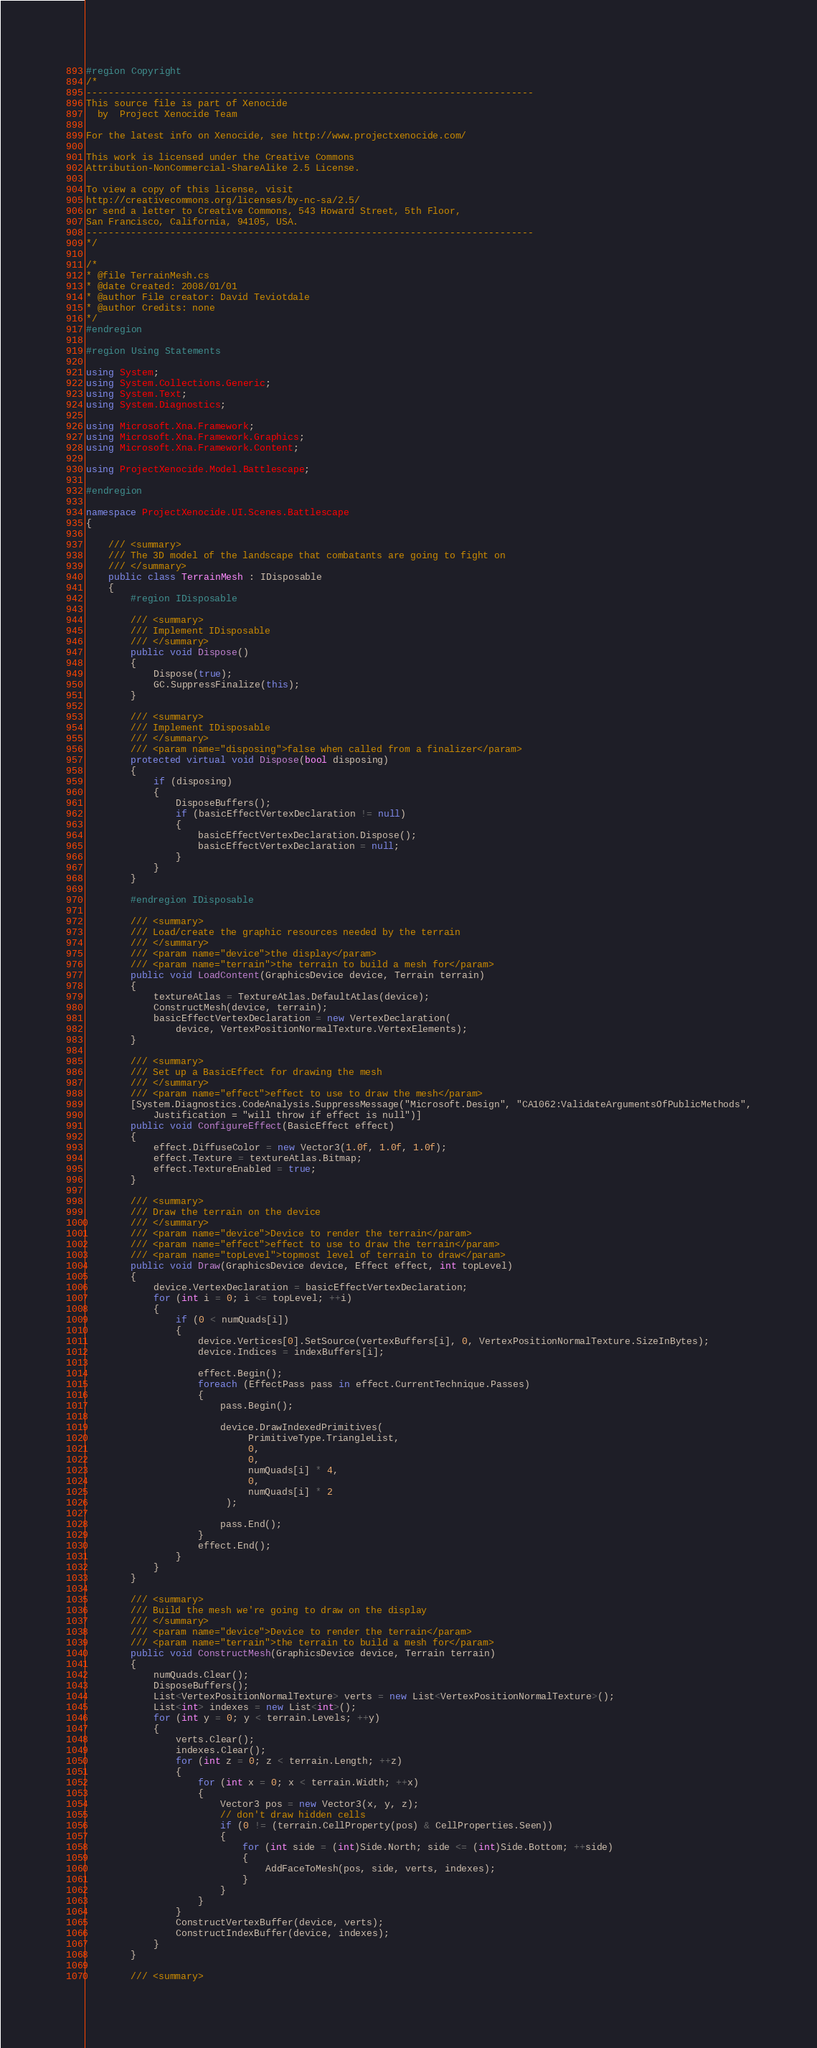Convert code to text. <code><loc_0><loc_0><loc_500><loc_500><_C#_>#region Copyright
/*
--------------------------------------------------------------------------------
This source file is part of Xenocide
  by  Project Xenocide Team

For the latest info on Xenocide, see http://www.projectxenocide.com/

This work is licensed under the Creative Commons
Attribution-NonCommercial-ShareAlike 2.5 License.

To view a copy of this license, visit
http://creativecommons.org/licenses/by-nc-sa/2.5/
or send a letter to Creative Commons, 543 Howard Street, 5th Floor,
San Francisco, California, 94105, USA.
--------------------------------------------------------------------------------
*/

/*
* @file TerrainMesh.cs
* @date Created: 2008/01/01
* @author File creator: David Teviotdale
* @author Credits: none
*/
#endregion

#region Using Statements

using System;
using System.Collections.Generic;
using System.Text;
using System.Diagnostics;

using Microsoft.Xna.Framework;
using Microsoft.Xna.Framework.Graphics;
using Microsoft.Xna.Framework.Content;

using ProjectXenocide.Model.Battlescape;

#endregion

namespace ProjectXenocide.UI.Scenes.Battlescape
{

    /// <summary>
    /// The 3D model of the landscape that combatants are going to fight on
    /// </summary>
    public class TerrainMesh : IDisposable
    {
        #region IDisposable

        /// <summary>
        /// Implement IDisposable
        /// </summary>
        public void Dispose()
        {
            Dispose(true);
            GC.SuppressFinalize(this);
        }

        /// <summary>
        /// Implement IDisposable
        /// </summary>
        /// <param name="disposing">false when called from a finalizer</param>
        protected virtual void Dispose(bool disposing)
        {
            if (disposing)
            {
                DisposeBuffers();
                if (basicEffectVertexDeclaration != null)
                {
                    basicEffectVertexDeclaration.Dispose();
                    basicEffectVertexDeclaration = null;
                }
            }
        }

        #endregion IDisposable

        /// <summary>
        /// Load/create the graphic resources needed by the terrain
        /// </summary>
        /// <param name="device">the display</param>
        /// <param name="terrain">the terrain to build a mesh for</param>
        public void LoadContent(GraphicsDevice device, Terrain terrain)
        {
            textureAtlas = TextureAtlas.DefaultAtlas(device);
            ConstructMesh(device, terrain);
            basicEffectVertexDeclaration = new VertexDeclaration(
                device, VertexPositionNormalTexture.VertexElements);
        }

        /// <summary>
        /// Set up a BasicEffect for drawing the mesh
        /// </summary>
        /// <param name="effect">effect to use to draw the mesh</param>
        [System.Diagnostics.CodeAnalysis.SuppressMessage("Microsoft.Design", "CA1062:ValidateArgumentsOfPublicMethods",
            Justification = "will throw if effect is null")]
        public void ConfigureEffect(BasicEffect effect)
        {
            effect.DiffuseColor = new Vector3(1.0f, 1.0f, 1.0f);
            effect.Texture = textureAtlas.Bitmap;
            effect.TextureEnabled = true;
        }

        /// <summary>
        /// Draw the terrain on the device
        /// </summary>
        /// <param name="device">Device to render the terrain</param>
        /// <param name="effect">effect to use to draw the terrain</param>
        /// <param name="topLevel">topmost level of terrain to draw</param>
        public void Draw(GraphicsDevice device, Effect effect, int topLevel)
        {
            device.VertexDeclaration = basicEffectVertexDeclaration;
            for (int i = 0; i <= topLevel; ++i)
            {
                if (0 < numQuads[i])
                {
                    device.Vertices[0].SetSource(vertexBuffers[i], 0, VertexPositionNormalTexture.SizeInBytes);
                    device.Indices = indexBuffers[i];

                    effect.Begin();
                    foreach (EffectPass pass in effect.CurrentTechnique.Passes)
                    {
                        pass.Begin();

                        device.DrawIndexedPrimitives(
                             PrimitiveType.TriangleList,
                             0,
                             0,
                             numQuads[i] * 4,
                             0,
                             numQuads[i] * 2
                         );

                        pass.End();
                    }
                    effect.End();
                }
            }
        }

        /// <summary>
        /// Build the mesh we're going to draw on the display
        /// </summary>
        /// <param name="device">Device to render the terrain</param>
        /// <param name="terrain">the terrain to build a mesh for</param>
        public void ConstructMesh(GraphicsDevice device, Terrain terrain)
        {
            numQuads.Clear();
            DisposeBuffers();
            List<VertexPositionNormalTexture> verts = new List<VertexPositionNormalTexture>();
            List<int> indexes = new List<int>();
            for (int y = 0; y < terrain.Levels; ++y)
            {
                verts.Clear();
                indexes.Clear();
                for (int z = 0; z < terrain.Length; ++z)
                {
                    for (int x = 0; x < terrain.Width; ++x)
                    {
                        Vector3 pos = new Vector3(x, y, z);
                        // don't draw hidden cells
                        if (0 != (terrain.CellProperty(pos) & CellProperties.Seen))
                        {
                            for (int side = (int)Side.North; side <= (int)Side.Bottom; ++side)
                            {
                                AddFaceToMesh(pos, side, verts, indexes);
                            }
                        }
                    }
                }
                ConstructVertexBuffer(device, verts);
                ConstructIndexBuffer(device, indexes);
            }
        }

        /// <summary></code> 